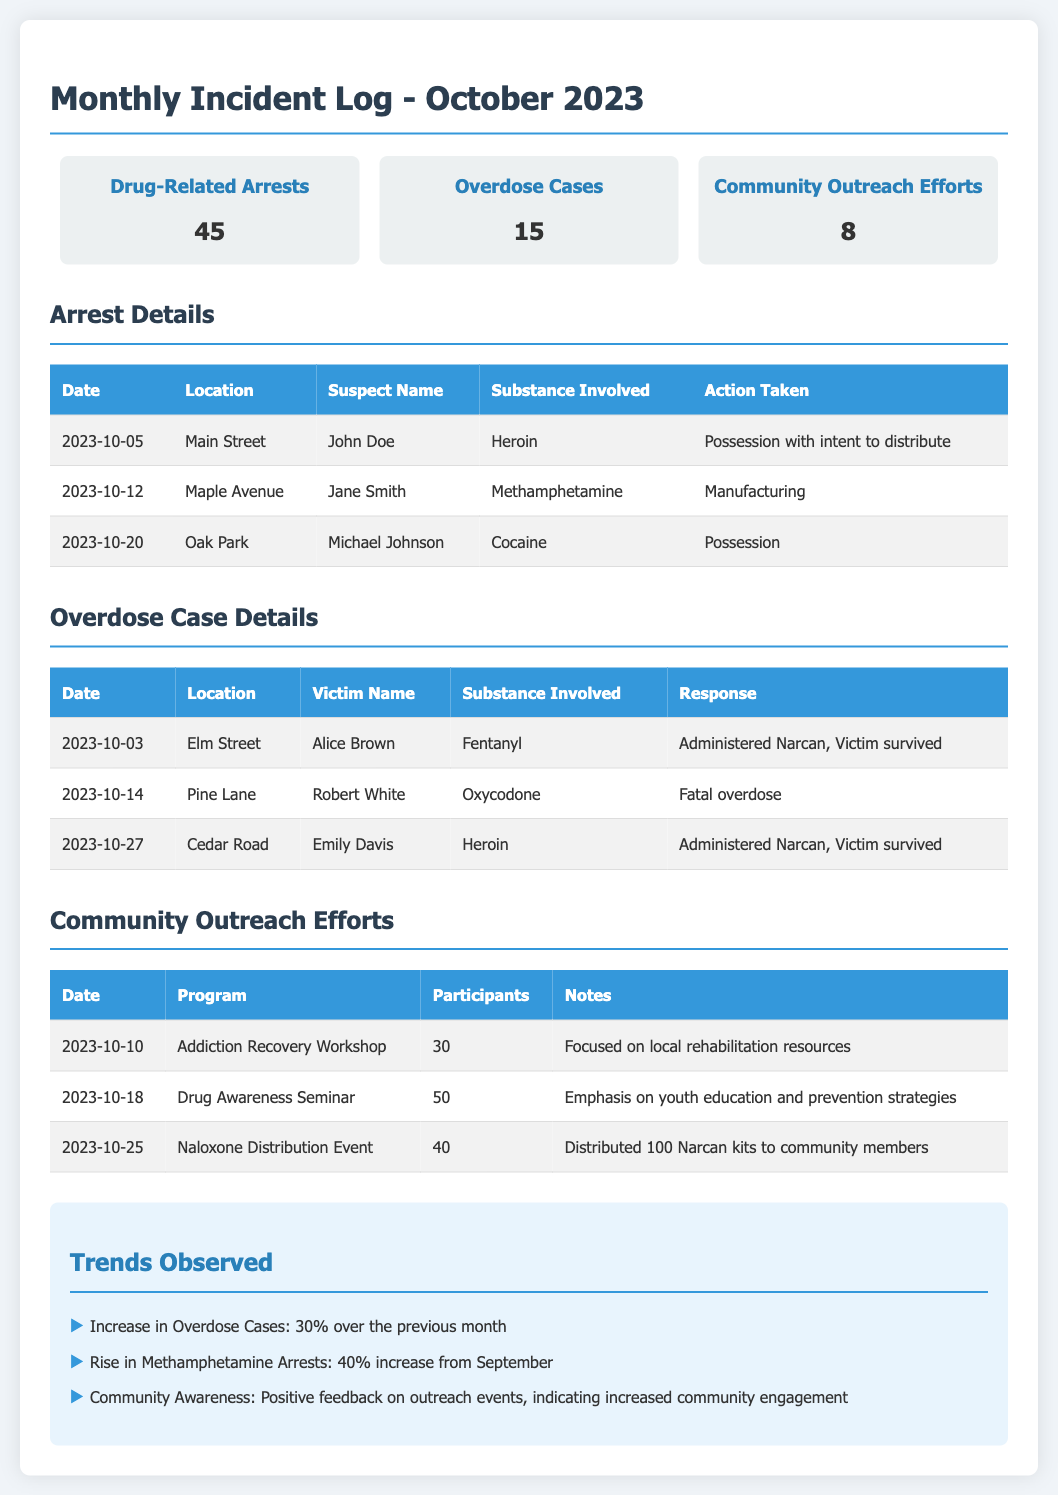what was the total number of drug-related arrests? The total number of drug-related arrests listed in the overview is 45.
Answer: 45 how many overdose cases occurred this month? The number of overdose cases recorded in the overview is 15.
Answer: 15 what substance was involved in John Doe's arrest? John Doe was arrested for possession with intent to distribute heroin.
Answer: Heroin who was the victim in the fatal overdose case? The victim in the fatal overdose case was Robert White.
Answer: Robert White what percentage increase is observed in overdose cases compared to the previous month? The document states there was a 30% increase in overdose cases over the previous month.
Answer: 30% which community outreach program had the most participants? The Drug Awareness Seminar had the most participants with 50 attendees.
Answer: Drug Awareness Seminar when did the Naloxone Distribution Event take place? The Naloxone Distribution Event occurred on October 25, 2023.
Answer: October 25, 2023 what trend was observed regarding methamphetamine arrests? There was a 40% increase in methamphetamine arrests noted in the trends section.
Answer: 40% increase how many community outreach efforts were reported this month? The document indicates that there were 8 community outreach efforts reported this month.
Answer: 8 